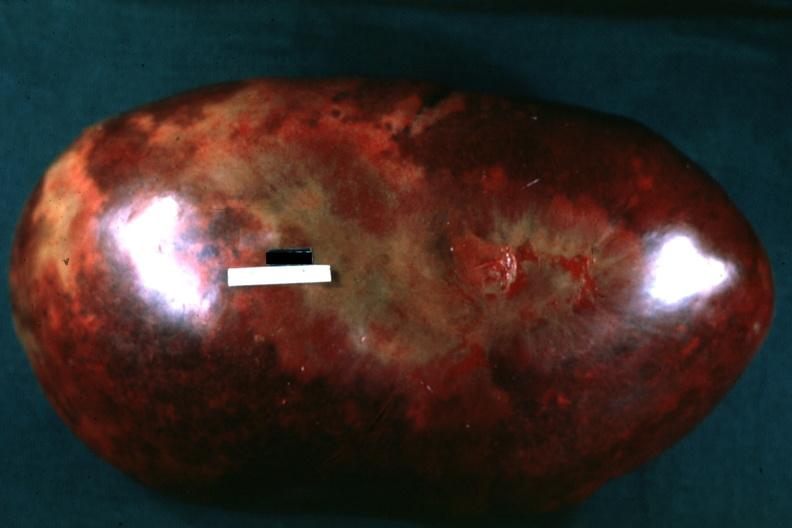does this image show massively enlarged spleen with large infarcts seen from capsule?
Answer the question using a single word or phrase. Yes 